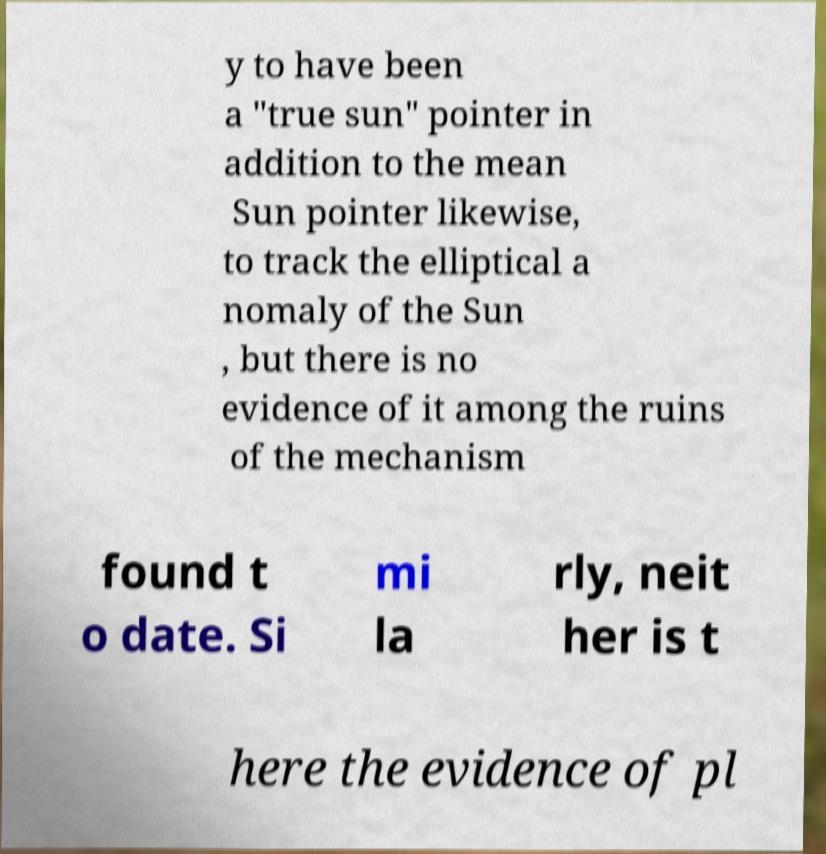Please read and relay the text visible in this image. What does it say? y to have been a "true sun" pointer in addition to the mean Sun pointer likewise, to track the elliptical a nomaly of the Sun , but there is no evidence of it among the ruins of the mechanism found t o date. Si mi la rly, neit her is t here the evidence of pl 